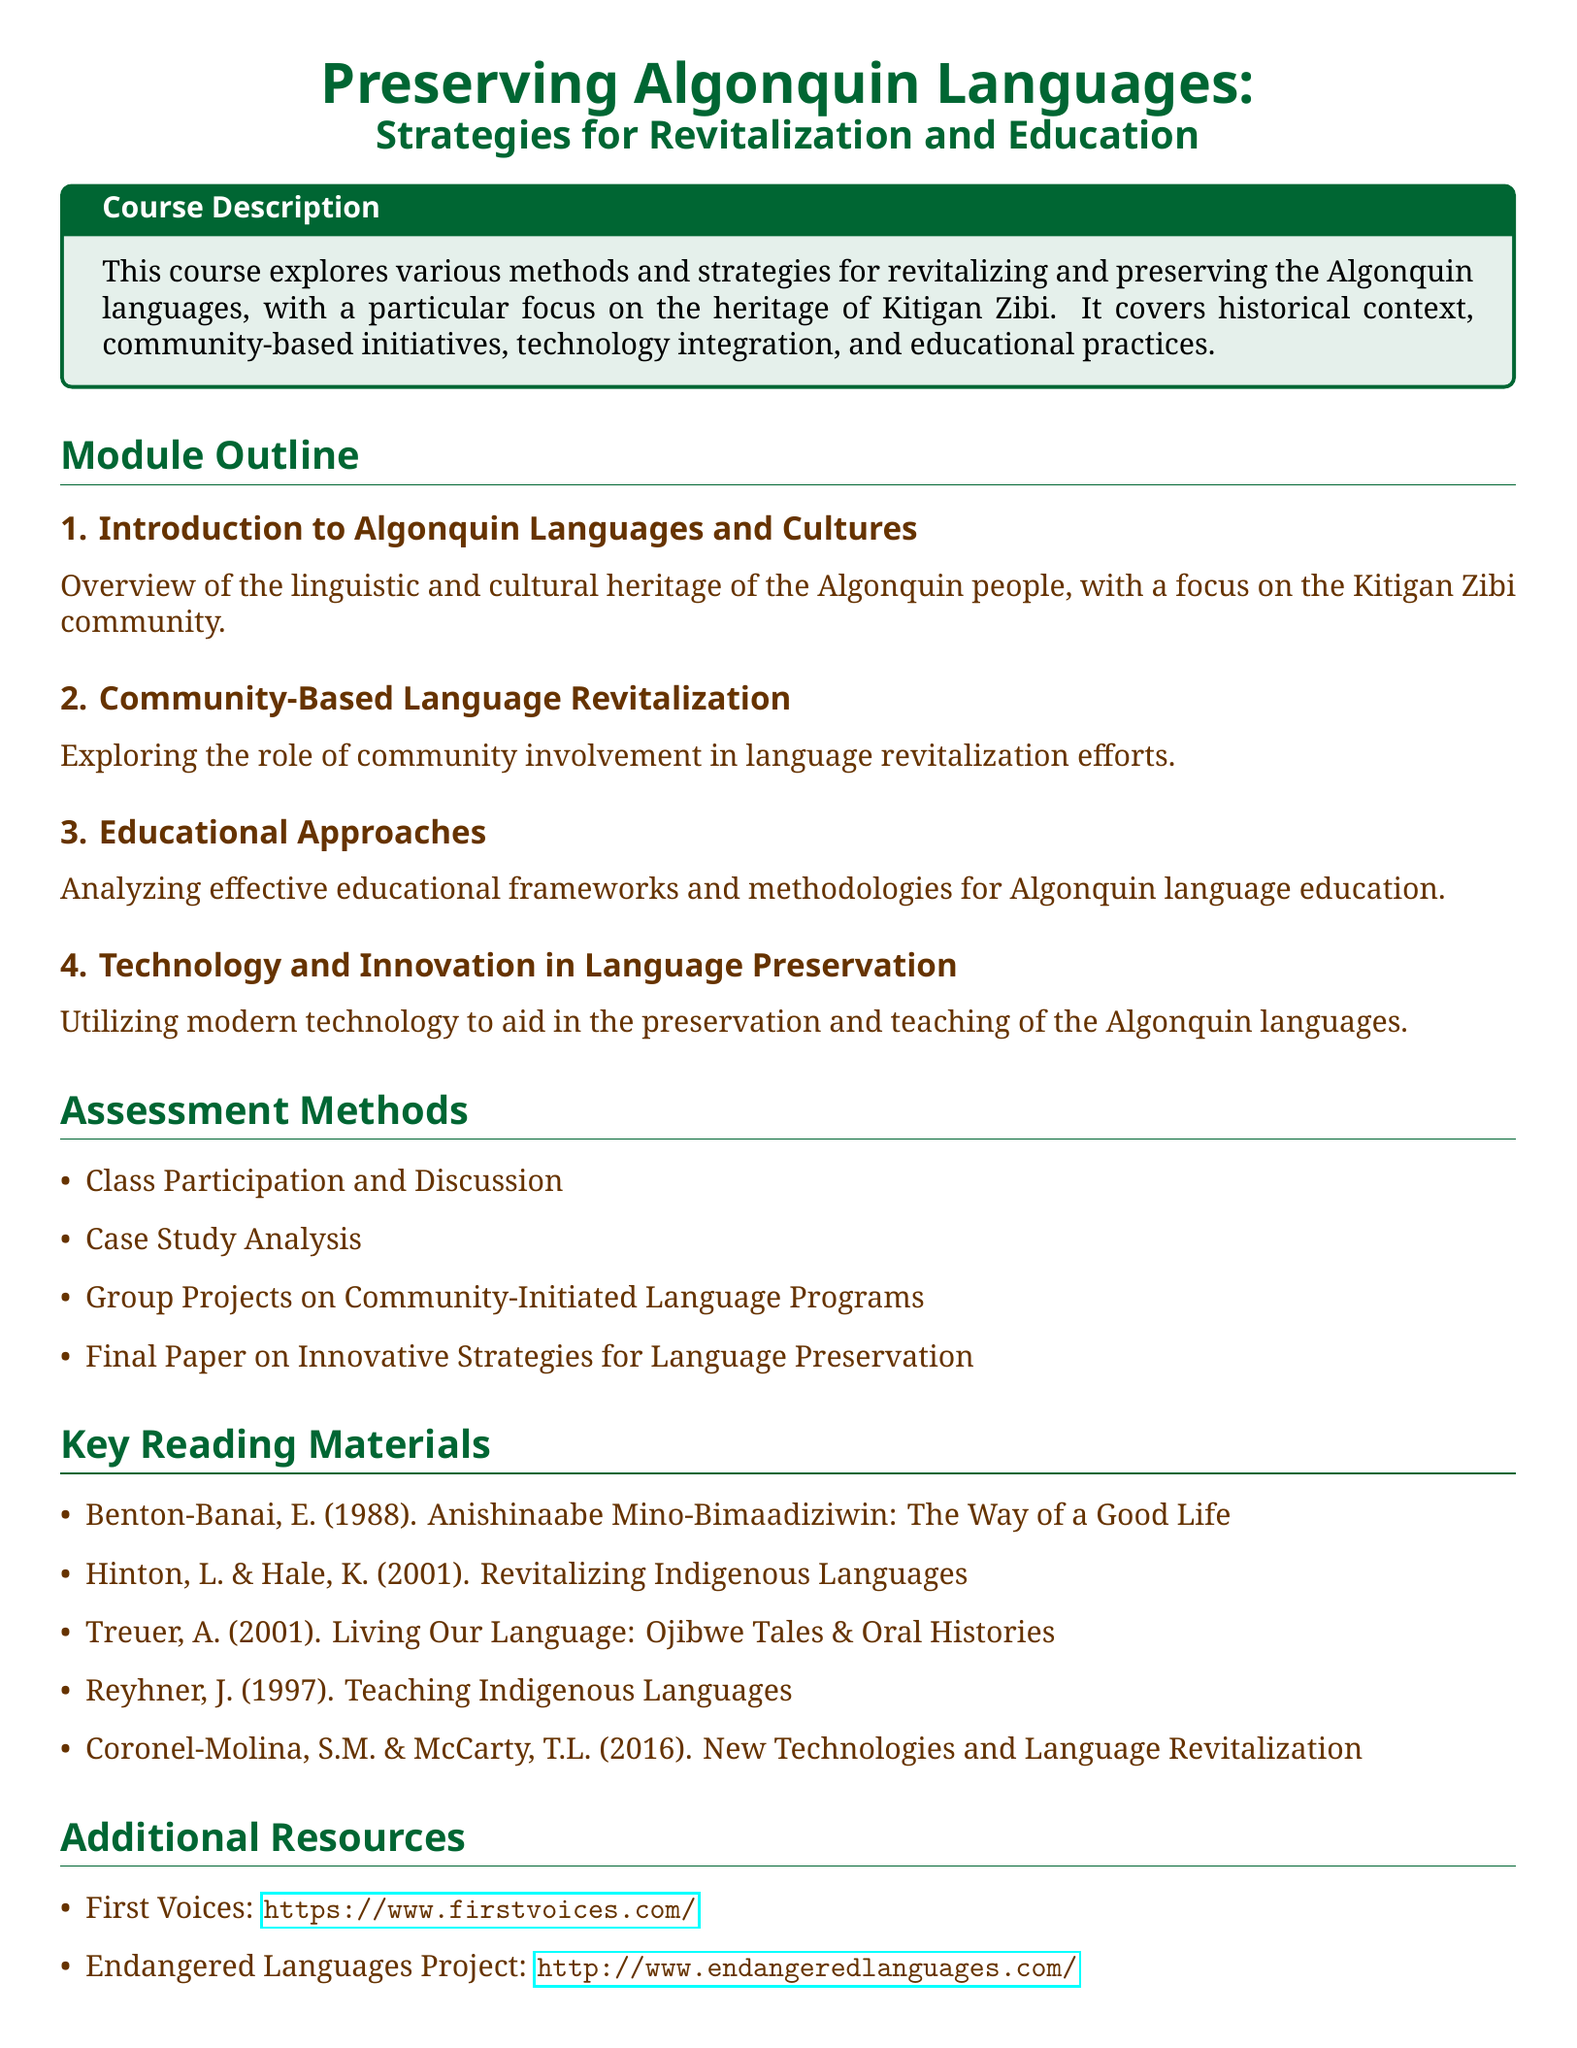What is the title of the course? The title of the course is clearly stated at the beginning of the document.
Answer: Preserving Algonquin Languages: Strategies for Revitalization and Education What is the focus community mentioned in the course description? The course description highlights a specific community for emphasis in language preservation efforts.
Answer: Kitigan Zibi What is the first module of the syllabus? The first module title is listed under the module outline section.
Answer: Introduction to Algonquin Languages and Cultures What type of assessment involves group work? The assessment methods section outlines various types of evaluations, including one that specifically mentions collaboration.
Answer: Group Projects on Community-Initiated Language Programs Which author wrote "Living Our Language: Ojibwe Tales & Oral Histories"? The key reading materials include the authors and their works, identifying the author of this specific title.
Answer: Treuer What is the total number of modules outlined in the syllabus? The modules are enumerated in the document, allowing for a count of them.
Answer: 4 What kind of resources are included in the additional resources section? The additional resources section lists types of resources for further research on language preservation.
Answer: Websites What is one method mentioned for language preservation? The document outlines various strategies and methodologies, specifically in the context of technology use.
Answer: Technology and Innovation in Language Preservation 